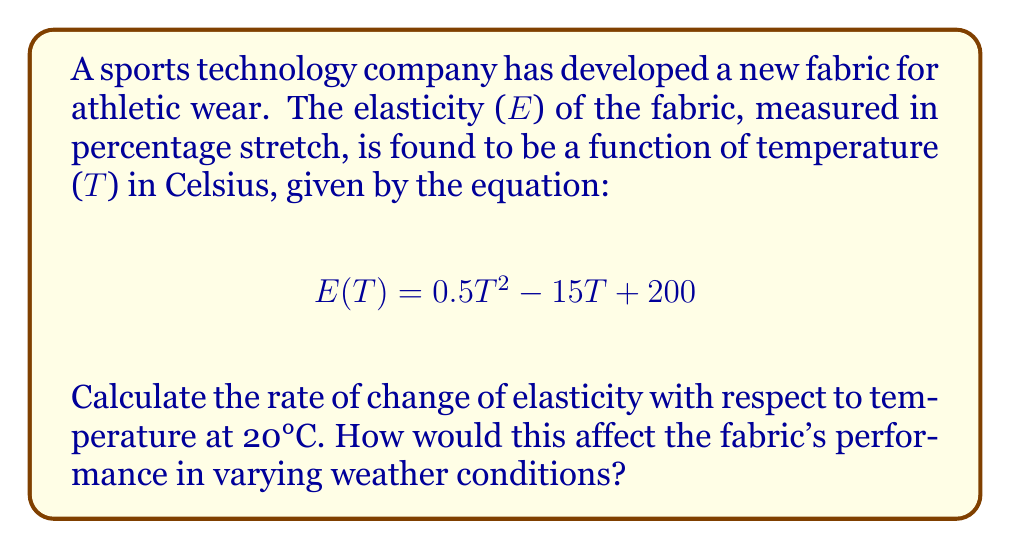Solve this math problem. To solve this problem, we need to follow these steps:

1) The rate of change of elasticity with respect to temperature is given by the derivative of E(T) with respect to T.

2) Let's find the derivative of E(T):
   $$\frac{d}{dT}E(T) = \frac{d}{dT}(0.5T^2 - 15T + 200)$$
   $$E'(T) = 0.5 \cdot 2T - 15 = T - 15$$

3) Now, we need to evaluate this derivative at T = 20°C:
   $$E'(20) = 20 - 15 = 5$$

4) Interpretation: 
   The rate of change of elasticity at 20°C is 5% per degree Celsius. This means that for each degree increase in temperature around 20°C, the fabric's elasticity increases by 5 percentage points.

5) Impact on performance:
   This positive rate of change indicates that the fabric becomes more elastic as temperature increases. In colder weather, the fabric will be less elastic, potentially providing more support but less flexibility. In warmer weather, the fabric will become more elastic, offering greater flexibility but possibly less support. This property could be advantageous for athletes adapting to different climates or for designing sport-specific gear.
Answer: 5% per °C 